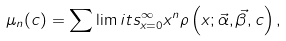Convert formula to latex. <formula><loc_0><loc_0><loc_500><loc_500>\mu _ { n } ( c ) = \sum \lim i t s _ { x = 0 } ^ { \infty } x ^ { n } \rho \left ( x ; \vec { \alpha } , \vec { \beta } , c \right ) ,</formula> 